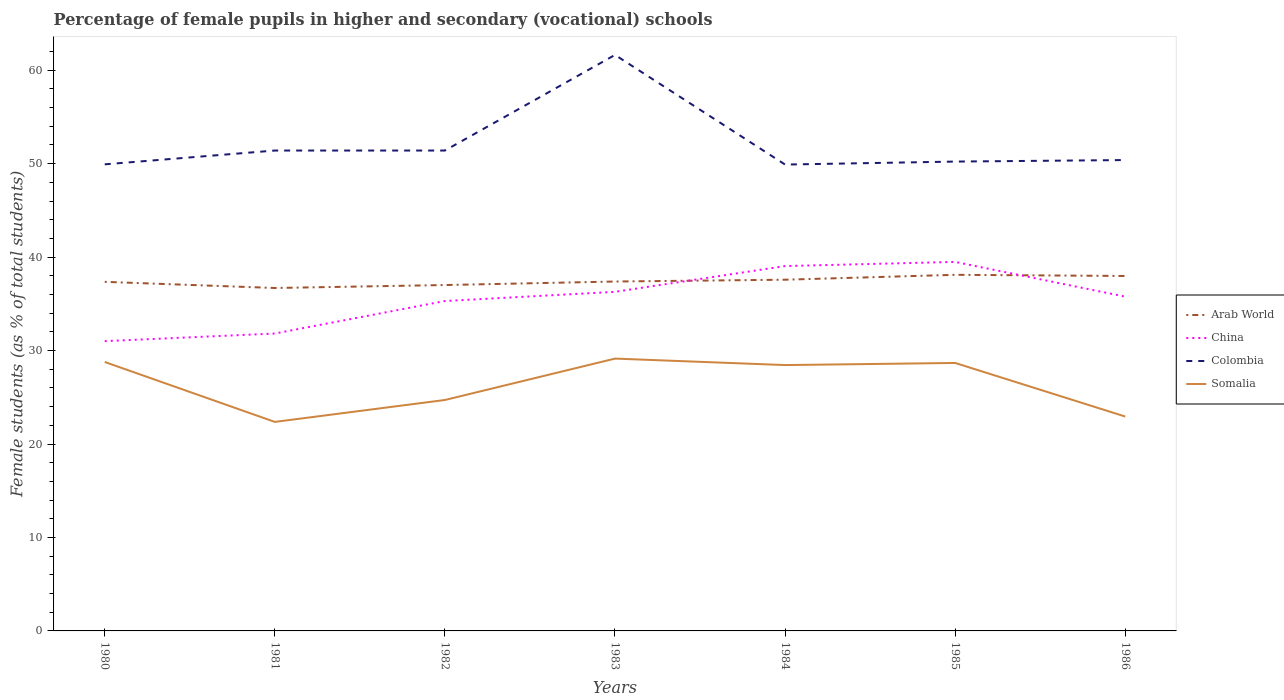Across all years, what is the maximum percentage of female pupils in higher and secondary schools in China?
Ensure brevity in your answer.  31.01. In which year was the percentage of female pupils in higher and secondary schools in Arab World maximum?
Provide a succinct answer. 1981. What is the total percentage of female pupils in higher and secondary schools in China in the graph?
Provide a short and direct response. -2.76. What is the difference between the highest and the second highest percentage of female pupils in higher and secondary schools in Somalia?
Your answer should be very brief. 6.77. Is the percentage of female pupils in higher and secondary schools in Somalia strictly greater than the percentage of female pupils in higher and secondary schools in China over the years?
Offer a terse response. Yes. How many years are there in the graph?
Keep it short and to the point. 7. Are the values on the major ticks of Y-axis written in scientific E-notation?
Your answer should be compact. No. Does the graph contain any zero values?
Offer a terse response. No. Where does the legend appear in the graph?
Provide a short and direct response. Center right. What is the title of the graph?
Your answer should be compact. Percentage of female pupils in higher and secondary (vocational) schools. What is the label or title of the Y-axis?
Offer a very short reply. Female students (as % of total students). What is the Female students (as % of total students) in Arab World in 1980?
Offer a very short reply. 37.35. What is the Female students (as % of total students) in China in 1980?
Ensure brevity in your answer.  31.01. What is the Female students (as % of total students) in Colombia in 1980?
Make the answer very short. 49.92. What is the Female students (as % of total students) of Somalia in 1980?
Ensure brevity in your answer.  28.78. What is the Female students (as % of total students) in Arab World in 1981?
Make the answer very short. 36.69. What is the Female students (as % of total students) of China in 1981?
Offer a very short reply. 31.82. What is the Female students (as % of total students) in Colombia in 1981?
Offer a terse response. 51.4. What is the Female students (as % of total students) in Somalia in 1981?
Your answer should be very brief. 22.36. What is the Female students (as % of total students) of Arab World in 1982?
Give a very brief answer. 37.01. What is the Female students (as % of total students) of China in 1982?
Give a very brief answer. 35.3. What is the Female students (as % of total students) of Colombia in 1982?
Make the answer very short. 51.4. What is the Female students (as % of total students) in Somalia in 1982?
Offer a terse response. 24.71. What is the Female students (as % of total students) in Arab World in 1983?
Ensure brevity in your answer.  37.39. What is the Female students (as % of total students) of China in 1983?
Offer a terse response. 36.28. What is the Female students (as % of total students) of Colombia in 1983?
Offer a terse response. 61.63. What is the Female students (as % of total students) of Somalia in 1983?
Ensure brevity in your answer.  29.14. What is the Female students (as % of total students) in Arab World in 1984?
Ensure brevity in your answer.  37.58. What is the Female students (as % of total students) in China in 1984?
Ensure brevity in your answer.  39.04. What is the Female students (as % of total students) of Colombia in 1984?
Make the answer very short. 49.9. What is the Female students (as % of total students) in Somalia in 1984?
Your answer should be very brief. 28.45. What is the Female students (as % of total students) of Arab World in 1985?
Keep it short and to the point. 38.1. What is the Female students (as % of total students) in China in 1985?
Make the answer very short. 39.48. What is the Female students (as % of total students) of Colombia in 1985?
Your response must be concise. 50.22. What is the Female students (as % of total students) of Somalia in 1985?
Your answer should be very brief. 28.67. What is the Female students (as % of total students) in Arab World in 1986?
Your answer should be compact. 37.98. What is the Female students (as % of total students) of China in 1986?
Give a very brief answer. 35.77. What is the Female students (as % of total students) in Colombia in 1986?
Your answer should be compact. 50.38. What is the Female students (as % of total students) in Somalia in 1986?
Your answer should be compact. 22.94. Across all years, what is the maximum Female students (as % of total students) in Arab World?
Provide a succinct answer. 38.1. Across all years, what is the maximum Female students (as % of total students) in China?
Keep it short and to the point. 39.48. Across all years, what is the maximum Female students (as % of total students) in Colombia?
Make the answer very short. 61.63. Across all years, what is the maximum Female students (as % of total students) in Somalia?
Make the answer very short. 29.14. Across all years, what is the minimum Female students (as % of total students) of Arab World?
Provide a succinct answer. 36.69. Across all years, what is the minimum Female students (as % of total students) of China?
Offer a terse response. 31.01. Across all years, what is the minimum Female students (as % of total students) in Colombia?
Your answer should be very brief. 49.9. Across all years, what is the minimum Female students (as % of total students) in Somalia?
Keep it short and to the point. 22.36. What is the total Female students (as % of total students) of Arab World in the graph?
Offer a terse response. 262.1. What is the total Female students (as % of total students) of China in the graph?
Keep it short and to the point. 248.7. What is the total Female students (as % of total students) in Colombia in the graph?
Provide a short and direct response. 364.86. What is the total Female students (as % of total students) in Somalia in the graph?
Give a very brief answer. 185.05. What is the difference between the Female students (as % of total students) in Arab World in 1980 and that in 1981?
Keep it short and to the point. 0.66. What is the difference between the Female students (as % of total students) in China in 1980 and that in 1981?
Give a very brief answer. -0.82. What is the difference between the Female students (as % of total students) of Colombia in 1980 and that in 1981?
Keep it short and to the point. -1.48. What is the difference between the Female students (as % of total students) in Somalia in 1980 and that in 1981?
Give a very brief answer. 6.41. What is the difference between the Female students (as % of total students) of Arab World in 1980 and that in 1982?
Your answer should be compact. 0.34. What is the difference between the Female students (as % of total students) in China in 1980 and that in 1982?
Ensure brevity in your answer.  -4.29. What is the difference between the Female students (as % of total students) in Colombia in 1980 and that in 1982?
Make the answer very short. -1.48. What is the difference between the Female students (as % of total students) in Somalia in 1980 and that in 1982?
Offer a very short reply. 4.07. What is the difference between the Female students (as % of total students) in Arab World in 1980 and that in 1983?
Provide a short and direct response. -0.03. What is the difference between the Female students (as % of total students) of China in 1980 and that in 1983?
Your answer should be compact. -5.28. What is the difference between the Female students (as % of total students) in Colombia in 1980 and that in 1983?
Make the answer very short. -11.71. What is the difference between the Female students (as % of total students) of Somalia in 1980 and that in 1983?
Provide a succinct answer. -0.36. What is the difference between the Female students (as % of total students) in Arab World in 1980 and that in 1984?
Offer a terse response. -0.23. What is the difference between the Female students (as % of total students) of China in 1980 and that in 1984?
Offer a terse response. -8.03. What is the difference between the Female students (as % of total students) in Colombia in 1980 and that in 1984?
Keep it short and to the point. 0.02. What is the difference between the Female students (as % of total students) of Somalia in 1980 and that in 1984?
Offer a terse response. 0.33. What is the difference between the Female students (as % of total students) in Arab World in 1980 and that in 1985?
Provide a short and direct response. -0.75. What is the difference between the Female students (as % of total students) of China in 1980 and that in 1985?
Give a very brief answer. -8.48. What is the difference between the Female students (as % of total students) in Colombia in 1980 and that in 1985?
Your response must be concise. -0.3. What is the difference between the Female students (as % of total students) of Somalia in 1980 and that in 1985?
Your answer should be very brief. 0.11. What is the difference between the Female students (as % of total students) of Arab World in 1980 and that in 1986?
Your answer should be compact. -0.63. What is the difference between the Female students (as % of total students) of China in 1980 and that in 1986?
Provide a short and direct response. -4.76. What is the difference between the Female students (as % of total students) in Colombia in 1980 and that in 1986?
Provide a succinct answer. -0.46. What is the difference between the Female students (as % of total students) in Somalia in 1980 and that in 1986?
Make the answer very short. 5.84. What is the difference between the Female students (as % of total students) in Arab World in 1981 and that in 1982?
Provide a short and direct response. -0.32. What is the difference between the Female students (as % of total students) of China in 1981 and that in 1982?
Your answer should be compact. -3.48. What is the difference between the Female students (as % of total students) in Colombia in 1981 and that in 1982?
Ensure brevity in your answer.  0. What is the difference between the Female students (as % of total students) in Somalia in 1981 and that in 1982?
Make the answer very short. -2.34. What is the difference between the Female students (as % of total students) of Arab World in 1981 and that in 1983?
Your response must be concise. -0.69. What is the difference between the Female students (as % of total students) of China in 1981 and that in 1983?
Provide a succinct answer. -4.46. What is the difference between the Female students (as % of total students) in Colombia in 1981 and that in 1983?
Offer a terse response. -10.23. What is the difference between the Female students (as % of total students) in Somalia in 1981 and that in 1983?
Ensure brevity in your answer.  -6.77. What is the difference between the Female students (as % of total students) in Arab World in 1981 and that in 1984?
Your answer should be very brief. -0.89. What is the difference between the Female students (as % of total students) in China in 1981 and that in 1984?
Ensure brevity in your answer.  -7.22. What is the difference between the Female students (as % of total students) in Colombia in 1981 and that in 1984?
Offer a very short reply. 1.5. What is the difference between the Female students (as % of total students) in Somalia in 1981 and that in 1984?
Provide a succinct answer. -6.08. What is the difference between the Female students (as % of total students) in Arab World in 1981 and that in 1985?
Your answer should be very brief. -1.41. What is the difference between the Female students (as % of total students) of China in 1981 and that in 1985?
Give a very brief answer. -7.66. What is the difference between the Female students (as % of total students) of Colombia in 1981 and that in 1985?
Provide a short and direct response. 1.18. What is the difference between the Female students (as % of total students) of Somalia in 1981 and that in 1985?
Provide a short and direct response. -6.31. What is the difference between the Female students (as % of total students) of Arab World in 1981 and that in 1986?
Your answer should be very brief. -1.29. What is the difference between the Female students (as % of total students) in China in 1981 and that in 1986?
Give a very brief answer. -3.95. What is the difference between the Female students (as % of total students) in Colombia in 1981 and that in 1986?
Offer a very short reply. 1.02. What is the difference between the Female students (as % of total students) of Somalia in 1981 and that in 1986?
Keep it short and to the point. -0.58. What is the difference between the Female students (as % of total students) of Arab World in 1982 and that in 1983?
Ensure brevity in your answer.  -0.38. What is the difference between the Female students (as % of total students) in China in 1982 and that in 1983?
Ensure brevity in your answer.  -0.99. What is the difference between the Female students (as % of total students) of Colombia in 1982 and that in 1983?
Give a very brief answer. -10.23. What is the difference between the Female students (as % of total students) in Somalia in 1982 and that in 1983?
Your response must be concise. -4.43. What is the difference between the Female students (as % of total students) of Arab World in 1982 and that in 1984?
Offer a terse response. -0.57. What is the difference between the Female students (as % of total students) of China in 1982 and that in 1984?
Make the answer very short. -3.74. What is the difference between the Female students (as % of total students) in Colombia in 1982 and that in 1984?
Ensure brevity in your answer.  1.5. What is the difference between the Female students (as % of total students) of Somalia in 1982 and that in 1984?
Your answer should be compact. -3.74. What is the difference between the Female students (as % of total students) in Arab World in 1982 and that in 1985?
Ensure brevity in your answer.  -1.09. What is the difference between the Female students (as % of total students) in China in 1982 and that in 1985?
Keep it short and to the point. -4.19. What is the difference between the Female students (as % of total students) in Colombia in 1982 and that in 1985?
Your response must be concise. 1.18. What is the difference between the Female students (as % of total students) in Somalia in 1982 and that in 1985?
Keep it short and to the point. -3.96. What is the difference between the Female students (as % of total students) in Arab World in 1982 and that in 1986?
Your answer should be very brief. -0.97. What is the difference between the Female students (as % of total students) of China in 1982 and that in 1986?
Ensure brevity in your answer.  -0.47. What is the difference between the Female students (as % of total students) in Colombia in 1982 and that in 1986?
Make the answer very short. 1.02. What is the difference between the Female students (as % of total students) in Somalia in 1982 and that in 1986?
Offer a terse response. 1.77. What is the difference between the Female students (as % of total students) in Arab World in 1983 and that in 1984?
Provide a succinct answer. -0.19. What is the difference between the Female students (as % of total students) of China in 1983 and that in 1984?
Your answer should be very brief. -2.76. What is the difference between the Female students (as % of total students) of Colombia in 1983 and that in 1984?
Ensure brevity in your answer.  11.73. What is the difference between the Female students (as % of total students) of Somalia in 1983 and that in 1984?
Provide a succinct answer. 0.69. What is the difference between the Female students (as % of total students) in Arab World in 1983 and that in 1985?
Provide a succinct answer. -0.72. What is the difference between the Female students (as % of total students) in China in 1983 and that in 1985?
Provide a short and direct response. -3.2. What is the difference between the Female students (as % of total students) in Colombia in 1983 and that in 1985?
Give a very brief answer. 11.41. What is the difference between the Female students (as % of total students) of Somalia in 1983 and that in 1985?
Your response must be concise. 0.47. What is the difference between the Female students (as % of total students) of Arab World in 1983 and that in 1986?
Your answer should be compact. -0.59. What is the difference between the Female students (as % of total students) of China in 1983 and that in 1986?
Your answer should be very brief. 0.52. What is the difference between the Female students (as % of total students) in Colombia in 1983 and that in 1986?
Your answer should be very brief. 11.25. What is the difference between the Female students (as % of total students) in Somalia in 1983 and that in 1986?
Your response must be concise. 6.2. What is the difference between the Female students (as % of total students) in Arab World in 1984 and that in 1985?
Provide a succinct answer. -0.52. What is the difference between the Female students (as % of total students) in China in 1984 and that in 1985?
Give a very brief answer. -0.45. What is the difference between the Female students (as % of total students) in Colombia in 1984 and that in 1985?
Ensure brevity in your answer.  -0.32. What is the difference between the Female students (as % of total students) in Somalia in 1984 and that in 1985?
Offer a very short reply. -0.23. What is the difference between the Female students (as % of total students) of Arab World in 1984 and that in 1986?
Give a very brief answer. -0.4. What is the difference between the Female students (as % of total students) of China in 1984 and that in 1986?
Make the answer very short. 3.27. What is the difference between the Female students (as % of total students) of Colombia in 1984 and that in 1986?
Make the answer very short. -0.48. What is the difference between the Female students (as % of total students) of Somalia in 1984 and that in 1986?
Give a very brief answer. 5.51. What is the difference between the Female students (as % of total students) of Arab World in 1985 and that in 1986?
Keep it short and to the point. 0.13. What is the difference between the Female students (as % of total students) in China in 1985 and that in 1986?
Your answer should be compact. 3.72. What is the difference between the Female students (as % of total students) in Colombia in 1985 and that in 1986?
Your answer should be very brief. -0.16. What is the difference between the Female students (as % of total students) in Somalia in 1985 and that in 1986?
Provide a succinct answer. 5.73. What is the difference between the Female students (as % of total students) in Arab World in 1980 and the Female students (as % of total students) in China in 1981?
Offer a very short reply. 5.53. What is the difference between the Female students (as % of total students) in Arab World in 1980 and the Female students (as % of total students) in Colombia in 1981?
Offer a terse response. -14.05. What is the difference between the Female students (as % of total students) in Arab World in 1980 and the Female students (as % of total students) in Somalia in 1981?
Your response must be concise. 14.99. What is the difference between the Female students (as % of total students) of China in 1980 and the Female students (as % of total students) of Colombia in 1981?
Your response must be concise. -20.4. What is the difference between the Female students (as % of total students) of China in 1980 and the Female students (as % of total students) of Somalia in 1981?
Make the answer very short. 8.64. What is the difference between the Female students (as % of total students) in Colombia in 1980 and the Female students (as % of total students) in Somalia in 1981?
Give a very brief answer. 27.56. What is the difference between the Female students (as % of total students) of Arab World in 1980 and the Female students (as % of total students) of China in 1982?
Your response must be concise. 2.05. What is the difference between the Female students (as % of total students) of Arab World in 1980 and the Female students (as % of total students) of Colombia in 1982?
Make the answer very short. -14.05. What is the difference between the Female students (as % of total students) in Arab World in 1980 and the Female students (as % of total students) in Somalia in 1982?
Your response must be concise. 12.64. What is the difference between the Female students (as % of total students) of China in 1980 and the Female students (as % of total students) of Colombia in 1982?
Offer a very short reply. -20.4. What is the difference between the Female students (as % of total students) in China in 1980 and the Female students (as % of total students) in Somalia in 1982?
Your answer should be very brief. 6.3. What is the difference between the Female students (as % of total students) in Colombia in 1980 and the Female students (as % of total students) in Somalia in 1982?
Your response must be concise. 25.22. What is the difference between the Female students (as % of total students) in Arab World in 1980 and the Female students (as % of total students) in China in 1983?
Offer a terse response. 1.07. What is the difference between the Female students (as % of total students) in Arab World in 1980 and the Female students (as % of total students) in Colombia in 1983?
Give a very brief answer. -24.28. What is the difference between the Female students (as % of total students) in Arab World in 1980 and the Female students (as % of total students) in Somalia in 1983?
Provide a short and direct response. 8.21. What is the difference between the Female students (as % of total students) of China in 1980 and the Female students (as % of total students) of Colombia in 1983?
Make the answer very short. -30.63. What is the difference between the Female students (as % of total students) in China in 1980 and the Female students (as % of total students) in Somalia in 1983?
Make the answer very short. 1.87. What is the difference between the Female students (as % of total students) of Colombia in 1980 and the Female students (as % of total students) of Somalia in 1983?
Provide a succinct answer. 20.79. What is the difference between the Female students (as % of total students) of Arab World in 1980 and the Female students (as % of total students) of China in 1984?
Your answer should be very brief. -1.69. What is the difference between the Female students (as % of total students) of Arab World in 1980 and the Female students (as % of total students) of Colombia in 1984?
Your response must be concise. -12.55. What is the difference between the Female students (as % of total students) in Arab World in 1980 and the Female students (as % of total students) in Somalia in 1984?
Make the answer very short. 8.91. What is the difference between the Female students (as % of total students) of China in 1980 and the Female students (as % of total students) of Colombia in 1984?
Make the answer very short. -18.89. What is the difference between the Female students (as % of total students) in China in 1980 and the Female students (as % of total students) in Somalia in 1984?
Offer a very short reply. 2.56. What is the difference between the Female students (as % of total students) of Colombia in 1980 and the Female students (as % of total students) of Somalia in 1984?
Provide a short and direct response. 21.48. What is the difference between the Female students (as % of total students) of Arab World in 1980 and the Female students (as % of total students) of China in 1985?
Your answer should be compact. -2.13. What is the difference between the Female students (as % of total students) of Arab World in 1980 and the Female students (as % of total students) of Colombia in 1985?
Provide a succinct answer. -12.87. What is the difference between the Female students (as % of total students) of Arab World in 1980 and the Female students (as % of total students) of Somalia in 1985?
Make the answer very short. 8.68. What is the difference between the Female students (as % of total students) of China in 1980 and the Female students (as % of total students) of Colombia in 1985?
Provide a succinct answer. -19.21. What is the difference between the Female students (as % of total students) in China in 1980 and the Female students (as % of total students) in Somalia in 1985?
Provide a succinct answer. 2.33. What is the difference between the Female students (as % of total students) of Colombia in 1980 and the Female students (as % of total students) of Somalia in 1985?
Provide a succinct answer. 21.25. What is the difference between the Female students (as % of total students) in Arab World in 1980 and the Female students (as % of total students) in China in 1986?
Your answer should be very brief. 1.58. What is the difference between the Female students (as % of total students) of Arab World in 1980 and the Female students (as % of total students) of Colombia in 1986?
Offer a terse response. -13.03. What is the difference between the Female students (as % of total students) of Arab World in 1980 and the Female students (as % of total students) of Somalia in 1986?
Your answer should be very brief. 14.41. What is the difference between the Female students (as % of total students) of China in 1980 and the Female students (as % of total students) of Colombia in 1986?
Provide a succinct answer. -19.38. What is the difference between the Female students (as % of total students) in China in 1980 and the Female students (as % of total students) in Somalia in 1986?
Keep it short and to the point. 8.07. What is the difference between the Female students (as % of total students) in Colombia in 1980 and the Female students (as % of total students) in Somalia in 1986?
Give a very brief answer. 26.98. What is the difference between the Female students (as % of total students) of Arab World in 1981 and the Female students (as % of total students) of China in 1982?
Offer a very short reply. 1.4. What is the difference between the Female students (as % of total students) in Arab World in 1981 and the Female students (as % of total students) in Colombia in 1982?
Provide a succinct answer. -14.71. What is the difference between the Female students (as % of total students) in Arab World in 1981 and the Female students (as % of total students) in Somalia in 1982?
Ensure brevity in your answer.  11.98. What is the difference between the Female students (as % of total students) in China in 1981 and the Female students (as % of total students) in Colombia in 1982?
Make the answer very short. -19.58. What is the difference between the Female students (as % of total students) in China in 1981 and the Female students (as % of total students) in Somalia in 1982?
Your answer should be compact. 7.11. What is the difference between the Female students (as % of total students) of Colombia in 1981 and the Female students (as % of total students) of Somalia in 1982?
Make the answer very short. 26.69. What is the difference between the Female students (as % of total students) of Arab World in 1981 and the Female students (as % of total students) of China in 1983?
Make the answer very short. 0.41. What is the difference between the Female students (as % of total students) in Arab World in 1981 and the Female students (as % of total students) in Colombia in 1983?
Provide a short and direct response. -24.94. What is the difference between the Female students (as % of total students) of Arab World in 1981 and the Female students (as % of total students) of Somalia in 1983?
Your answer should be very brief. 7.55. What is the difference between the Female students (as % of total students) of China in 1981 and the Female students (as % of total students) of Colombia in 1983?
Ensure brevity in your answer.  -29.81. What is the difference between the Female students (as % of total students) in China in 1981 and the Female students (as % of total students) in Somalia in 1983?
Offer a very short reply. 2.68. What is the difference between the Female students (as % of total students) of Colombia in 1981 and the Female students (as % of total students) of Somalia in 1983?
Ensure brevity in your answer.  22.26. What is the difference between the Female students (as % of total students) of Arab World in 1981 and the Female students (as % of total students) of China in 1984?
Your answer should be very brief. -2.35. What is the difference between the Female students (as % of total students) of Arab World in 1981 and the Female students (as % of total students) of Colombia in 1984?
Provide a short and direct response. -13.21. What is the difference between the Female students (as % of total students) of Arab World in 1981 and the Female students (as % of total students) of Somalia in 1984?
Offer a very short reply. 8.25. What is the difference between the Female students (as % of total students) in China in 1981 and the Female students (as % of total students) in Colombia in 1984?
Keep it short and to the point. -18.08. What is the difference between the Female students (as % of total students) of China in 1981 and the Female students (as % of total students) of Somalia in 1984?
Make the answer very short. 3.38. What is the difference between the Female students (as % of total students) in Colombia in 1981 and the Female students (as % of total students) in Somalia in 1984?
Your answer should be compact. 22.96. What is the difference between the Female students (as % of total students) in Arab World in 1981 and the Female students (as % of total students) in China in 1985?
Your response must be concise. -2.79. What is the difference between the Female students (as % of total students) in Arab World in 1981 and the Female students (as % of total students) in Colombia in 1985?
Offer a very short reply. -13.53. What is the difference between the Female students (as % of total students) in Arab World in 1981 and the Female students (as % of total students) in Somalia in 1985?
Ensure brevity in your answer.  8.02. What is the difference between the Female students (as % of total students) of China in 1981 and the Female students (as % of total students) of Colombia in 1985?
Your answer should be very brief. -18.4. What is the difference between the Female students (as % of total students) in China in 1981 and the Female students (as % of total students) in Somalia in 1985?
Offer a terse response. 3.15. What is the difference between the Female students (as % of total students) of Colombia in 1981 and the Female students (as % of total students) of Somalia in 1985?
Ensure brevity in your answer.  22.73. What is the difference between the Female students (as % of total students) in Arab World in 1981 and the Female students (as % of total students) in China in 1986?
Give a very brief answer. 0.93. What is the difference between the Female students (as % of total students) of Arab World in 1981 and the Female students (as % of total students) of Colombia in 1986?
Provide a succinct answer. -13.69. What is the difference between the Female students (as % of total students) in Arab World in 1981 and the Female students (as % of total students) in Somalia in 1986?
Provide a succinct answer. 13.75. What is the difference between the Female students (as % of total students) in China in 1981 and the Female students (as % of total students) in Colombia in 1986?
Give a very brief answer. -18.56. What is the difference between the Female students (as % of total students) in China in 1981 and the Female students (as % of total students) in Somalia in 1986?
Provide a succinct answer. 8.88. What is the difference between the Female students (as % of total students) of Colombia in 1981 and the Female students (as % of total students) of Somalia in 1986?
Provide a succinct answer. 28.46. What is the difference between the Female students (as % of total students) of Arab World in 1982 and the Female students (as % of total students) of China in 1983?
Provide a succinct answer. 0.73. What is the difference between the Female students (as % of total students) of Arab World in 1982 and the Female students (as % of total students) of Colombia in 1983?
Offer a terse response. -24.62. What is the difference between the Female students (as % of total students) in Arab World in 1982 and the Female students (as % of total students) in Somalia in 1983?
Give a very brief answer. 7.87. What is the difference between the Female students (as % of total students) in China in 1982 and the Female students (as % of total students) in Colombia in 1983?
Offer a very short reply. -26.33. What is the difference between the Female students (as % of total students) of China in 1982 and the Female students (as % of total students) of Somalia in 1983?
Provide a short and direct response. 6.16. What is the difference between the Female students (as % of total students) of Colombia in 1982 and the Female students (as % of total students) of Somalia in 1983?
Offer a very short reply. 22.26. What is the difference between the Female students (as % of total students) of Arab World in 1982 and the Female students (as % of total students) of China in 1984?
Your answer should be compact. -2.03. What is the difference between the Female students (as % of total students) of Arab World in 1982 and the Female students (as % of total students) of Colombia in 1984?
Give a very brief answer. -12.89. What is the difference between the Female students (as % of total students) of Arab World in 1982 and the Female students (as % of total students) of Somalia in 1984?
Provide a short and direct response. 8.56. What is the difference between the Female students (as % of total students) of China in 1982 and the Female students (as % of total students) of Colombia in 1984?
Your response must be concise. -14.6. What is the difference between the Female students (as % of total students) in China in 1982 and the Female students (as % of total students) in Somalia in 1984?
Provide a succinct answer. 6.85. What is the difference between the Female students (as % of total students) of Colombia in 1982 and the Female students (as % of total students) of Somalia in 1984?
Offer a terse response. 22.95. What is the difference between the Female students (as % of total students) of Arab World in 1982 and the Female students (as % of total students) of China in 1985?
Your answer should be very brief. -2.47. What is the difference between the Female students (as % of total students) in Arab World in 1982 and the Female students (as % of total students) in Colombia in 1985?
Your answer should be compact. -13.21. What is the difference between the Female students (as % of total students) in Arab World in 1982 and the Female students (as % of total students) in Somalia in 1985?
Offer a very short reply. 8.34. What is the difference between the Female students (as % of total students) of China in 1982 and the Female students (as % of total students) of Colombia in 1985?
Make the answer very short. -14.92. What is the difference between the Female students (as % of total students) in China in 1982 and the Female students (as % of total students) in Somalia in 1985?
Your answer should be compact. 6.63. What is the difference between the Female students (as % of total students) of Colombia in 1982 and the Female students (as % of total students) of Somalia in 1985?
Your answer should be compact. 22.73. What is the difference between the Female students (as % of total students) in Arab World in 1982 and the Female students (as % of total students) in China in 1986?
Your answer should be compact. 1.24. What is the difference between the Female students (as % of total students) in Arab World in 1982 and the Female students (as % of total students) in Colombia in 1986?
Provide a short and direct response. -13.37. What is the difference between the Female students (as % of total students) of Arab World in 1982 and the Female students (as % of total students) of Somalia in 1986?
Offer a terse response. 14.07. What is the difference between the Female students (as % of total students) in China in 1982 and the Female students (as % of total students) in Colombia in 1986?
Your response must be concise. -15.08. What is the difference between the Female students (as % of total students) in China in 1982 and the Female students (as % of total students) in Somalia in 1986?
Offer a terse response. 12.36. What is the difference between the Female students (as % of total students) in Colombia in 1982 and the Female students (as % of total students) in Somalia in 1986?
Provide a succinct answer. 28.46. What is the difference between the Female students (as % of total students) of Arab World in 1983 and the Female students (as % of total students) of China in 1984?
Keep it short and to the point. -1.65. What is the difference between the Female students (as % of total students) of Arab World in 1983 and the Female students (as % of total students) of Colombia in 1984?
Provide a short and direct response. -12.52. What is the difference between the Female students (as % of total students) of Arab World in 1983 and the Female students (as % of total students) of Somalia in 1984?
Provide a succinct answer. 8.94. What is the difference between the Female students (as % of total students) in China in 1983 and the Female students (as % of total students) in Colombia in 1984?
Offer a very short reply. -13.62. What is the difference between the Female students (as % of total students) of China in 1983 and the Female students (as % of total students) of Somalia in 1984?
Provide a succinct answer. 7.84. What is the difference between the Female students (as % of total students) of Colombia in 1983 and the Female students (as % of total students) of Somalia in 1984?
Offer a very short reply. 33.19. What is the difference between the Female students (as % of total students) of Arab World in 1983 and the Female students (as % of total students) of China in 1985?
Ensure brevity in your answer.  -2.1. What is the difference between the Female students (as % of total students) in Arab World in 1983 and the Female students (as % of total students) in Colombia in 1985?
Your response must be concise. -12.83. What is the difference between the Female students (as % of total students) in Arab World in 1983 and the Female students (as % of total students) in Somalia in 1985?
Make the answer very short. 8.71. What is the difference between the Female students (as % of total students) in China in 1983 and the Female students (as % of total students) in Colombia in 1985?
Your answer should be very brief. -13.94. What is the difference between the Female students (as % of total students) in China in 1983 and the Female students (as % of total students) in Somalia in 1985?
Ensure brevity in your answer.  7.61. What is the difference between the Female students (as % of total students) in Colombia in 1983 and the Female students (as % of total students) in Somalia in 1985?
Your response must be concise. 32.96. What is the difference between the Female students (as % of total students) of Arab World in 1983 and the Female students (as % of total students) of China in 1986?
Offer a terse response. 1.62. What is the difference between the Female students (as % of total students) in Arab World in 1983 and the Female students (as % of total students) in Colombia in 1986?
Make the answer very short. -13. What is the difference between the Female students (as % of total students) of Arab World in 1983 and the Female students (as % of total students) of Somalia in 1986?
Your response must be concise. 14.45. What is the difference between the Female students (as % of total students) of China in 1983 and the Female students (as % of total students) of Colombia in 1986?
Your response must be concise. -14.1. What is the difference between the Female students (as % of total students) of China in 1983 and the Female students (as % of total students) of Somalia in 1986?
Your answer should be compact. 13.34. What is the difference between the Female students (as % of total students) of Colombia in 1983 and the Female students (as % of total students) of Somalia in 1986?
Provide a short and direct response. 38.69. What is the difference between the Female students (as % of total students) in Arab World in 1984 and the Female students (as % of total students) in China in 1985?
Your answer should be compact. -1.9. What is the difference between the Female students (as % of total students) of Arab World in 1984 and the Female students (as % of total students) of Colombia in 1985?
Offer a very short reply. -12.64. What is the difference between the Female students (as % of total students) in Arab World in 1984 and the Female students (as % of total students) in Somalia in 1985?
Provide a short and direct response. 8.91. What is the difference between the Female students (as % of total students) in China in 1984 and the Female students (as % of total students) in Colombia in 1985?
Provide a succinct answer. -11.18. What is the difference between the Female students (as % of total students) in China in 1984 and the Female students (as % of total students) in Somalia in 1985?
Provide a succinct answer. 10.37. What is the difference between the Female students (as % of total students) of Colombia in 1984 and the Female students (as % of total students) of Somalia in 1985?
Provide a short and direct response. 21.23. What is the difference between the Female students (as % of total students) of Arab World in 1984 and the Female students (as % of total students) of China in 1986?
Your response must be concise. 1.81. What is the difference between the Female students (as % of total students) of Arab World in 1984 and the Female students (as % of total students) of Colombia in 1986?
Keep it short and to the point. -12.8. What is the difference between the Female students (as % of total students) of Arab World in 1984 and the Female students (as % of total students) of Somalia in 1986?
Your response must be concise. 14.64. What is the difference between the Female students (as % of total students) of China in 1984 and the Female students (as % of total students) of Colombia in 1986?
Your response must be concise. -11.34. What is the difference between the Female students (as % of total students) in China in 1984 and the Female students (as % of total students) in Somalia in 1986?
Your answer should be compact. 16.1. What is the difference between the Female students (as % of total students) in Colombia in 1984 and the Female students (as % of total students) in Somalia in 1986?
Offer a very short reply. 26.96. What is the difference between the Female students (as % of total students) of Arab World in 1985 and the Female students (as % of total students) of China in 1986?
Your response must be concise. 2.34. What is the difference between the Female students (as % of total students) in Arab World in 1985 and the Female students (as % of total students) in Colombia in 1986?
Make the answer very short. -12.28. What is the difference between the Female students (as % of total students) in Arab World in 1985 and the Female students (as % of total students) in Somalia in 1986?
Make the answer very short. 15.16. What is the difference between the Female students (as % of total students) in China in 1985 and the Female students (as % of total students) in Colombia in 1986?
Make the answer very short. -10.9. What is the difference between the Female students (as % of total students) in China in 1985 and the Female students (as % of total students) in Somalia in 1986?
Offer a very short reply. 16.54. What is the difference between the Female students (as % of total students) in Colombia in 1985 and the Female students (as % of total students) in Somalia in 1986?
Your answer should be very brief. 27.28. What is the average Female students (as % of total students) of Arab World per year?
Give a very brief answer. 37.44. What is the average Female students (as % of total students) of China per year?
Make the answer very short. 35.53. What is the average Female students (as % of total students) of Colombia per year?
Your response must be concise. 52.12. What is the average Female students (as % of total students) of Somalia per year?
Your answer should be compact. 26.44. In the year 1980, what is the difference between the Female students (as % of total students) of Arab World and Female students (as % of total students) of China?
Offer a very short reply. 6.35. In the year 1980, what is the difference between the Female students (as % of total students) of Arab World and Female students (as % of total students) of Colombia?
Give a very brief answer. -12.57. In the year 1980, what is the difference between the Female students (as % of total students) of Arab World and Female students (as % of total students) of Somalia?
Offer a very short reply. 8.57. In the year 1980, what is the difference between the Female students (as % of total students) of China and Female students (as % of total students) of Colombia?
Keep it short and to the point. -18.92. In the year 1980, what is the difference between the Female students (as % of total students) in China and Female students (as % of total students) in Somalia?
Offer a terse response. 2.23. In the year 1980, what is the difference between the Female students (as % of total students) in Colombia and Female students (as % of total students) in Somalia?
Provide a succinct answer. 21.15. In the year 1981, what is the difference between the Female students (as % of total students) in Arab World and Female students (as % of total students) in China?
Give a very brief answer. 4.87. In the year 1981, what is the difference between the Female students (as % of total students) in Arab World and Female students (as % of total students) in Colombia?
Keep it short and to the point. -14.71. In the year 1981, what is the difference between the Female students (as % of total students) in Arab World and Female students (as % of total students) in Somalia?
Make the answer very short. 14.33. In the year 1981, what is the difference between the Female students (as % of total students) of China and Female students (as % of total students) of Colombia?
Give a very brief answer. -19.58. In the year 1981, what is the difference between the Female students (as % of total students) in China and Female students (as % of total students) in Somalia?
Ensure brevity in your answer.  9.46. In the year 1981, what is the difference between the Female students (as % of total students) of Colombia and Female students (as % of total students) of Somalia?
Give a very brief answer. 29.04. In the year 1982, what is the difference between the Female students (as % of total students) in Arab World and Female students (as % of total students) in China?
Offer a terse response. 1.71. In the year 1982, what is the difference between the Female students (as % of total students) in Arab World and Female students (as % of total students) in Colombia?
Ensure brevity in your answer.  -14.39. In the year 1982, what is the difference between the Female students (as % of total students) of Arab World and Female students (as % of total students) of Somalia?
Your answer should be very brief. 12.3. In the year 1982, what is the difference between the Female students (as % of total students) of China and Female students (as % of total students) of Colombia?
Ensure brevity in your answer.  -16.1. In the year 1982, what is the difference between the Female students (as % of total students) of China and Female students (as % of total students) of Somalia?
Your answer should be very brief. 10.59. In the year 1982, what is the difference between the Female students (as % of total students) of Colombia and Female students (as % of total students) of Somalia?
Your answer should be compact. 26.69. In the year 1983, what is the difference between the Female students (as % of total students) in Arab World and Female students (as % of total students) in China?
Your answer should be compact. 1.1. In the year 1983, what is the difference between the Female students (as % of total students) in Arab World and Female students (as % of total students) in Colombia?
Offer a very short reply. -24.25. In the year 1983, what is the difference between the Female students (as % of total students) of Arab World and Female students (as % of total students) of Somalia?
Ensure brevity in your answer.  8.25. In the year 1983, what is the difference between the Female students (as % of total students) in China and Female students (as % of total students) in Colombia?
Provide a short and direct response. -25.35. In the year 1983, what is the difference between the Female students (as % of total students) of China and Female students (as % of total students) of Somalia?
Provide a succinct answer. 7.14. In the year 1983, what is the difference between the Female students (as % of total students) in Colombia and Female students (as % of total students) in Somalia?
Provide a succinct answer. 32.49. In the year 1984, what is the difference between the Female students (as % of total students) in Arab World and Female students (as % of total students) in China?
Your response must be concise. -1.46. In the year 1984, what is the difference between the Female students (as % of total students) of Arab World and Female students (as % of total students) of Colombia?
Your response must be concise. -12.32. In the year 1984, what is the difference between the Female students (as % of total students) of Arab World and Female students (as % of total students) of Somalia?
Offer a very short reply. 9.13. In the year 1984, what is the difference between the Female students (as % of total students) in China and Female students (as % of total students) in Colombia?
Keep it short and to the point. -10.86. In the year 1984, what is the difference between the Female students (as % of total students) in China and Female students (as % of total students) in Somalia?
Your response must be concise. 10.59. In the year 1984, what is the difference between the Female students (as % of total students) of Colombia and Female students (as % of total students) of Somalia?
Keep it short and to the point. 21.45. In the year 1985, what is the difference between the Female students (as % of total students) in Arab World and Female students (as % of total students) in China?
Your response must be concise. -1.38. In the year 1985, what is the difference between the Female students (as % of total students) of Arab World and Female students (as % of total students) of Colombia?
Your answer should be compact. -12.12. In the year 1985, what is the difference between the Female students (as % of total students) of Arab World and Female students (as % of total students) of Somalia?
Provide a short and direct response. 9.43. In the year 1985, what is the difference between the Female students (as % of total students) of China and Female students (as % of total students) of Colombia?
Offer a very short reply. -10.74. In the year 1985, what is the difference between the Female students (as % of total students) of China and Female students (as % of total students) of Somalia?
Make the answer very short. 10.81. In the year 1985, what is the difference between the Female students (as % of total students) of Colombia and Female students (as % of total students) of Somalia?
Provide a short and direct response. 21.55. In the year 1986, what is the difference between the Female students (as % of total students) of Arab World and Female students (as % of total students) of China?
Provide a short and direct response. 2.21. In the year 1986, what is the difference between the Female students (as % of total students) of Arab World and Female students (as % of total students) of Colombia?
Keep it short and to the point. -12.4. In the year 1986, what is the difference between the Female students (as % of total students) in Arab World and Female students (as % of total students) in Somalia?
Ensure brevity in your answer.  15.04. In the year 1986, what is the difference between the Female students (as % of total students) of China and Female students (as % of total students) of Colombia?
Ensure brevity in your answer.  -14.62. In the year 1986, what is the difference between the Female students (as % of total students) of China and Female students (as % of total students) of Somalia?
Your answer should be very brief. 12.83. In the year 1986, what is the difference between the Female students (as % of total students) of Colombia and Female students (as % of total students) of Somalia?
Offer a terse response. 27.44. What is the ratio of the Female students (as % of total students) of China in 1980 to that in 1981?
Keep it short and to the point. 0.97. What is the ratio of the Female students (as % of total students) in Colombia in 1980 to that in 1981?
Provide a short and direct response. 0.97. What is the ratio of the Female students (as % of total students) in Somalia in 1980 to that in 1981?
Offer a very short reply. 1.29. What is the ratio of the Female students (as % of total students) in Arab World in 1980 to that in 1982?
Make the answer very short. 1.01. What is the ratio of the Female students (as % of total students) in China in 1980 to that in 1982?
Ensure brevity in your answer.  0.88. What is the ratio of the Female students (as % of total students) in Colombia in 1980 to that in 1982?
Your answer should be compact. 0.97. What is the ratio of the Female students (as % of total students) in Somalia in 1980 to that in 1982?
Offer a very short reply. 1.16. What is the ratio of the Female students (as % of total students) in China in 1980 to that in 1983?
Provide a succinct answer. 0.85. What is the ratio of the Female students (as % of total students) of Colombia in 1980 to that in 1983?
Provide a succinct answer. 0.81. What is the ratio of the Female students (as % of total students) of Somalia in 1980 to that in 1983?
Offer a terse response. 0.99. What is the ratio of the Female students (as % of total students) of Arab World in 1980 to that in 1984?
Keep it short and to the point. 0.99. What is the ratio of the Female students (as % of total students) in China in 1980 to that in 1984?
Give a very brief answer. 0.79. What is the ratio of the Female students (as % of total students) of Colombia in 1980 to that in 1984?
Provide a short and direct response. 1. What is the ratio of the Female students (as % of total students) in Somalia in 1980 to that in 1984?
Your response must be concise. 1.01. What is the ratio of the Female students (as % of total students) in Arab World in 1980 to that in 1985?
Offer a terse response. 0.98. What is the ratio of the Female students (as % of total students) of China in 1980 to that in 1985?
Offer a very short reply. 0.79. What is the ratio of the Female students (as % of total students) of Arab World in 1980 to that in 1986?
Your response must be concise. 0.98. What is the ratio of the Female students (as % of total students) in China in 1980 to that in 1986?
Your answer should be very brief. 0.87. What is the ratio of the Female students (as % of total students) in Colombia in 1980 to that in 1986?
Your response must be concise. 0.99. What is the ratio of the Female students (as % of total students) of Somalia in 1980 to that in 1986?
Provide a succinct answer. 1.25. What is the ratio of the Female students (as % of total students) of Arab World in 1981 to that in 1982?
Offer a terse response. 0.99. What is the ratio of the Female students (as % of total students) of China in 1981 to that in 1982?
Your response must be concise. 0.9. What is the ratio of the Female students (as % of total students) of Colombia in 1981 to that in 1982?
Keep it short and to the point. 1. What is the ratio of the Female students (as % of total students) in Somalia in 1981 to that in 1982?
Keep it short and to the point. 0.91. What is the ratio of the Female students (as % of total students) of Arab World in 1981 to that in 1983?
Your answer should be very brief. 0.98. What is the ratio of the Female students (as % of total students) of China in 1981 to that in 1983?
Offer a terse response. 0.88. What is the ratio of the Female students (as % of total students) of Colombia in 1981 to that in 1983?
Ensure brevity in your answer.  0.83. What is the ratio of the Female students (as % of total students) of Somalia in 1981 to that in 1983?
Ensure brevity in your answer.  0.77. What is the ratio of the Female students (as % of total students) in Arab World in 1981 to that in 1984?
Your response must be concise. 0.98. What is the ratio of the Female students (as % of total students) in China in 1981 to that in 1984?
Ensure brevity in your answer.  0.82. What is the ratio of the Female students (as % of total students) of Colombia in 1981 to that in 1984?
Offer a very short reply. 1.03. What is the ratio of the Female students (as % of total students) in Somalia in 1981 to that in 1984?
Provide a short and direct response. 0.79. What is the ratio of the Female students (as % of total students) of China in 1981 to that in 1985?
Make the answer very short. 0.81. What is the ratio of the Female students (as % of total students) in Colombia in 1981 to that in 1985?
Offer a terse response. 1.02. What is the ratio of the Female students (as % of total students) of Somalia in 1981 to that in 1985?
Your answer should be very brief. 0.78. What is the ratio of the Female students (as % of total students) of Arab World in 1981 to that in 1986?
Offer a very short reply. 0.97. What is the ratio of the Female students (as % of total students) of China in 1981 to that in 1986?
Provide a short and direct response. 0.89. What is the ratio of the Female students (as % of total students) of Colombia in 1981 to that in 1986?
Your response must be concise. 1.02. What is the ratio of the Female students (as % of total students) in Somalia in 1981 to that in 1986?
Your response must be concise. 0.97. What is the ratio of the Female students (as % of total students) of China in 1982 to that in 1983?
Your response must be concise. 0.97. What is the ratio of the Female students (as % of total students) of Colombia in 1982 to that in 1983?
Your answer should be very brief. 0.83. What is the ratio of the Female students (as % of total students) in Somalia in 1982 to that in 1983?
Offer a very short reply. 0.85. What is the ratio of the Female students (as % of total students) of China in 1982 to that in 1984?
Your answer should be compact. 0.9. What is the ratio of the Female students (as % of total students) in Colombia in 1982 to that in 1984?
Give a very brief answer. 1.03. What is the ratio of the Female students (as % of total students) in Somalia in 1982 to that in 1984?
Your response must be concise. 0.87. What is the ratio of the Female students (as % of total students) in Arab World in 1982 to that in 1985?
Make the answer very short. 0.97. What is the ratio of the Female students (as % of total students) in China in 1982 to that in 1985?
Offer a very short reply. 0.89. What is the ratio of the Female students (as % of total students) of Colombia in 1982 to that in 1985?
Ensure brevity in your answer.  1.02. What is the ratio of the Female students (as % of total students) of Somalia in 1982 to that in 1985?
Your answer should be very brief. 0.86. What is the ratio of the Female students (as % of total students) of Arab World in 1982 to that in 1986?
Ensure brevity in your answer.  0.97. What is the ratio of the Female students (as % of total students) in China in 1982 to that in 1986?
Give a very brief answer. 0.99. What is the ratio of the Female students (as % of total students) in Colombia in 1982 to that in 1986?
Provide a short and direct response. 1.02. What is the ratio of the Female students (as % of total students) in Somalia in 1982 to that in 1986?
Provide a short and direct response. 1.08. What is the ratio of the Female students (as % of total students) of China in 1983 to that in 1984?
Make the answer very short. 0.93. What is the ratio of the Female students (as % of total students) in Colombia in 1983 to that in 1984?
Offer a very short reply. 1.24. What is the ratio of the Female students (as % of total students) in Somalia in 1983 to that in 1984?
Your answer should be very brief. 1.02. What is the ratio of the Female students (as % of total students) of Arab World in 1983 to that in 1985?
Your response must be concise. 0.98. What is the ratio of the Female students (as % of total students) in China in 1983 to that in 1985?
Your answer should be compact. 0.92. What is the ratio of the Female students (as % of total students) of Colombia in 1983 to that in 1985?
Offer a terse response. 1.23. What is the ratio of the Female students (as % of total students) of Somalia in 1983 to that in 1985?
Make the answer very short. 1.02. What is the ratio of the Female students (as % of total students) of Arab World in 1983 to that in 1986?
Make the answer very short. 0.98. What is the ratio of the Female students (as % of total students) of China in 1983 to that in 1986?
Your answer should be compact. 1.01. What is the ratio of the Female students (as % of total students) of Colombia in 1983 to that in 1986?
Your response must be concise. 1.22. What is the ratio of the Female students (as % of total students) in Somalia in 1983 to that in 1986?
Provide a short and direct response. 1.27. What is the ratio of the Female students (as % of total students) of Arab World in 1984 to that in 1985?
Your answer should be compact. 0.99. What is the ratio of the Female students (as % of total students) of China in 1984 to that in 1985?
Give a very brief answer. 0.99. What is the ratio of the Female students (as % of total students) in Colombia in 1984 to that in 1985?
Your answer should be very brief. 0.99. What is the ratio of the Female students (as % of total students) of Somalia in 1984 to that in 1985?
Offer a terse response. 0.99. What is the ratio of the Female students (as % of total students) in Arab World in 1984 to that in 1986?
Give a very brief answer. 0.99. What is the ratio of the Female students (as % of total students) of China in 1984 to that in 1986?
Give a very brief answer. 1.09. What is the ratio of the Female students (as % of total students) in Somalia in 1984 to that in 1986?
Offer a very short reply. 1.24. What is the ratio of the Female students (as % of total students) in China in 1985 to that in 1986?
Your answer should be compact. 1.1. What is the ratio of the Female students (as % of total students) in Colombia in 1985 to that in 1986?
Ensure brevity in your answer.  1. What is the ratio of the Female students (as % of total students) of Somalia in 1985 to that in 1986?
Provide a succinct answer. 1.25. What is the difference between the highest and the second highest Female students (as % of total students) of Arab World?
Provide a succinct answer. 0.13. What is the difference between the highest and the second highest Female students (as % of total students) in China?
Make the answer very short. 0.45. What is the difference between the highest and the second highest Female students (as % of total students) of Colombia?
Your answer should be very brief. 10.23. What is the difference between the highest and the second highest Female students (as % of total students) of Somalia?
Your response must be concise. 0.36. What is the difference between the highest and the lowest Female students (as % of total students) in Arab World?
Keep it short and to the point. 1.41. What is the difference between the highest and the lowest Female students (as % of total students) of China?
Offer a terse response. 8.48. What is the difference between the highest and the lowest Female students (as % of total students) in Colombia?
Your response must be concise. 11.73. What is the difference between the highest and the lowest Female students (as % of total students) of Somalia?
Provide a short and direct response. 6.77. 